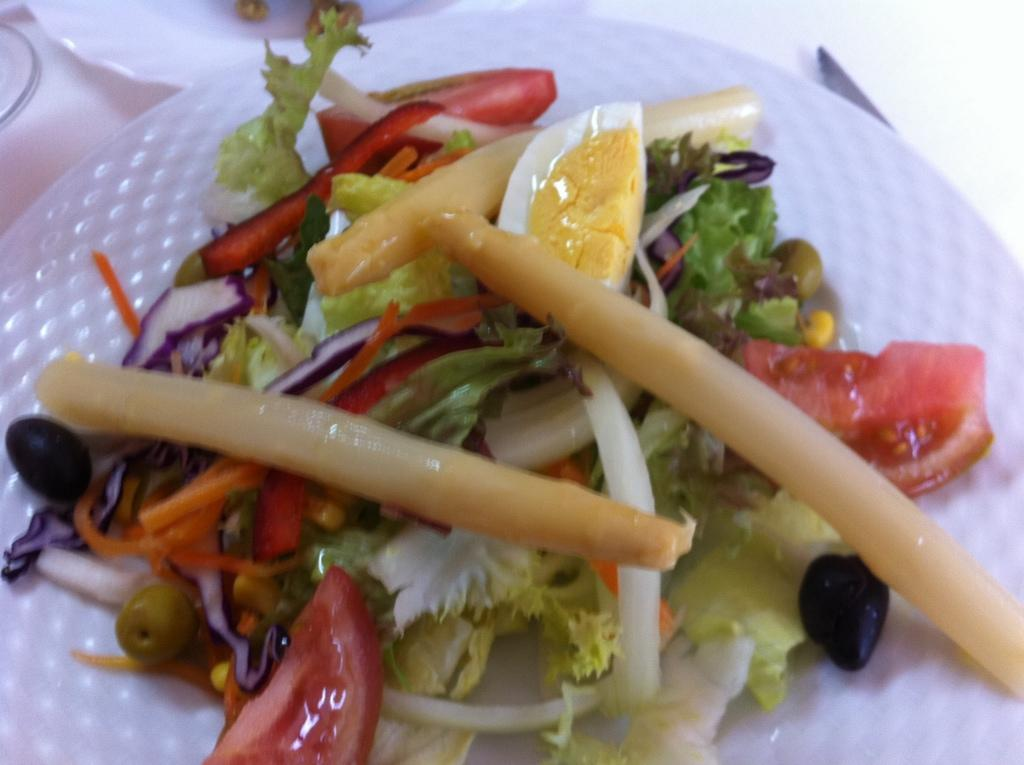What is present on the plate in the image? There is food in a plate in the image. What type of spoon is being used by the pets in the image? There are no pets or spoons present in the image; it only features a plate of food. 